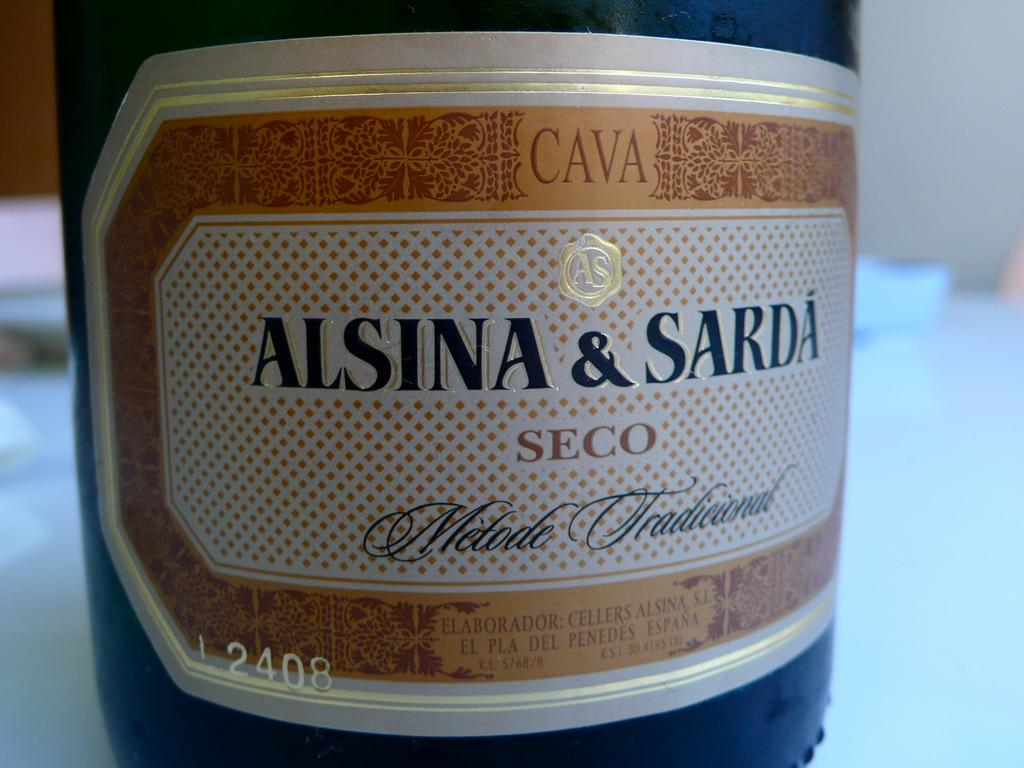<image>
Render a clear and concise summary of the photo. a close up of a sign for Cava Alsina & Sarda Seco 